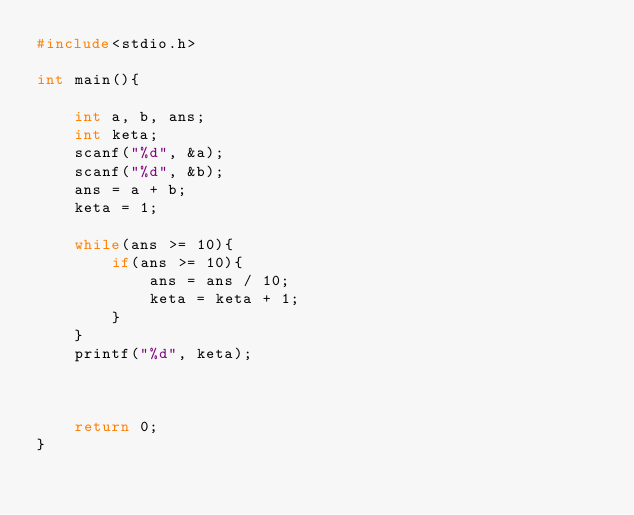<code> <loc_0><loc_0><loc_500><loc_500><_C_>#include<stdio.h>

int main(){

	int a, b, ans;
	int keta;
	scanf("%d", &a);
	scanf("%d", &b);
	ans = a + b;
	keta = 1;

	while(ans >= 10){
		if(ans >= 10){
			ans = ans / 10;
			keta = keta + 1;
		}
	}
	printf("%d", keta);



    return 0;
}</code> 